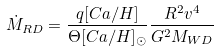<formula> <loc_0><loc_0><loc_500><loc_500>\dot { M } _ { R D } = \frac { q [ C a / H ] } { \Theta [ C a / H ] _ { \odot } } \frac { R ^ { 2 } v ^ { 4 } } { G ^ { 2 } M _ { W D } }</formula> 